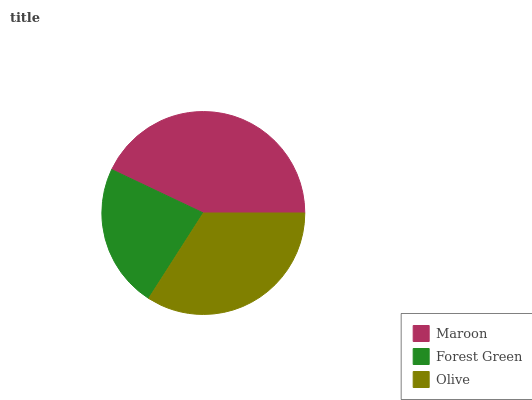Is Forest Green the minimum?
Answer yes or no. Yes. Is Maroon the maximum?
Answer yes or no. Yes. Is Olive the minimum?
Answer yes or no. No. Is Olive the maximum?
Answer yes or no. No. Is Olive greater than Forest Green?
Answer yes or no. Yes. Is Forest Green less than Olive?
Answer yes or no. Yes. Is Forest Green greater than Olive?
Answer yes or no. No. Is Olive less than Forest Green?
Answer yes or no. No. Is Olive the high median?
Answer yes or no. Yes. Is Olive the low median?
Answer yes or no. Yes. Is Forest Green the high median?
Answer yes or no. No. Is Forest Green the low median?
Answer yes or no. No. 